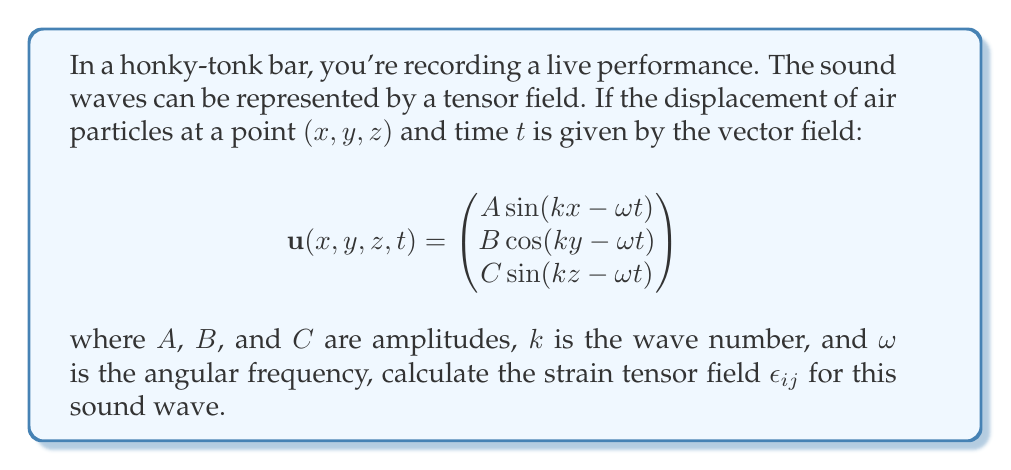Show me your answer to this math problem. Let's approach this step-by-step:

1) The strain tensor $\epsilon_{ij}$ is defined as:

   $$\epsilon_{ij} = \frac{1}{2}\left(\frac{\partial u_i}{\partial x_j} + \frac{\partial u_j}{\partial x_i}\right)$$

2) We need to calculate the partial derivatives:

   $$\frac{\partial u_x}{\partial x} = Ak \cos(kx - \omega t)$$
   $$\frac{\partial u_x}{\partial y} = 0$$
   $$\frac{\partial u_x}{\partial z} = 0$$
   $$\frac{\partial u_y}{\partial x} = 0$$
   $$\frac{\partial u_y}{\partial y} = -Bk \sin(ky - \omega t)$$
   $$\frac{\partial u_y}{\partial z} = 0$$
   $$\frac{\partial u_z}{\partial x} = 0$$
   $$\frac{\partial u_z}{\partial y} = 0$$
   $$\frac{\partial u_z}{\partial z} = Ck \cos(kz - \omega t)$$

3) Now we can calculate each component of the strain tensor:

   $$\epsilon_{xx} = \frac{\partial u_x}{\partial x} = Ak \cos(kx - \omega t)$$
   $$\epsilon_{yy} = \frac{\partial u_y}{\partial y} = -Bk \sin(ky - \omega t)$$
   $$\epsilon_{zz} = \frac{\partial u_z}{\partial z} = Ck \cos(kz - \omega t)$$
   $$\epsilon_{xy} = \epsilon_{yx} = \frac{1}{2}\left(\frac{\partial u_x}{\partial y} + \frac{\partial u_y}{\partial x}\right) = 0$$
   $$\epsilon_{xz} = \epsilon_{zx} = \frac{1}{2}\left(\frac{\partial u_x}{\partial z} + \frac{\partial u_z}{\partial x}\right) = 0$$
   $$\epsilon_{yz} = \epsilon_{zy} = \frac{1}{2}\left(\frac{\partial u_y}{\partial z} + \frac{\partial u_z}{\partial y}\right) = 0$$

4) Therefore, the strain tensor field is:

   $$\epsilon_{ij} = \begin{pmatrix}
   Ak \cos(kx - \omega t) & 0 & 0 \\
   0 & -Bk \sin(ky - \omega t) & 0 \\
   0 & 0 & Ck \cos(kz - \omega t)
   \end{pmatrix}$$
Answer: $$\epsilon_{ij} = \begin{pmatrix}
Ak \cos(kx - \omega t) & 0 & 0 \\
0 & -Bk \sin(ky - \omega t) & 0 \\
0 & 0 & Ck \cos(kz - \omega t)
\end{pmatrix}$$ 